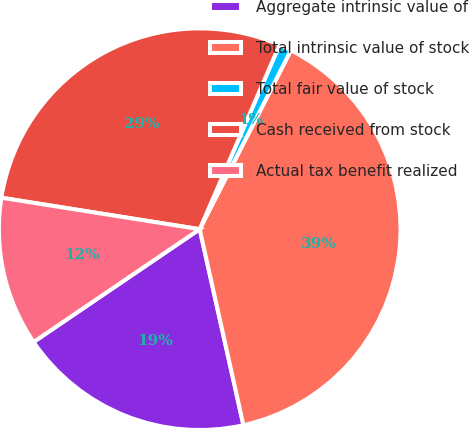Convert chart. <chart><loc_0><loc_0><loc_500><loc_500><pie_chart><fcel>Aggregate intrinsic value of<fcel>Total intrinsic value of stock<fcel>Total fair value of stock<fcel>Cash received from stock<fcel>Actual tax benefit realized<nl><fcel>19.0%<fcel>39.0%<fcel>1.0%<fcel>29.0%<fcel>12.0%<nl></chart> 